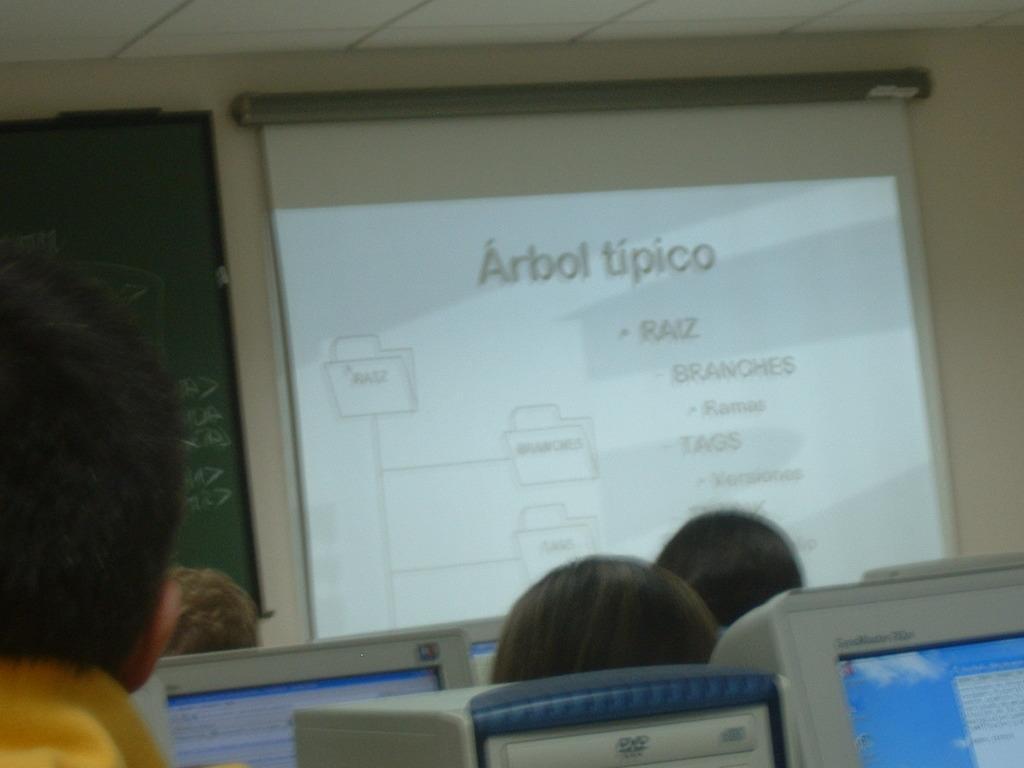How would you summarize this image in a sentence or two? Here in this picture we can see a projector screen present on the wall over there and beside that we can see a black board and in the front we can see people sitting on chairs with systems in front of them. 